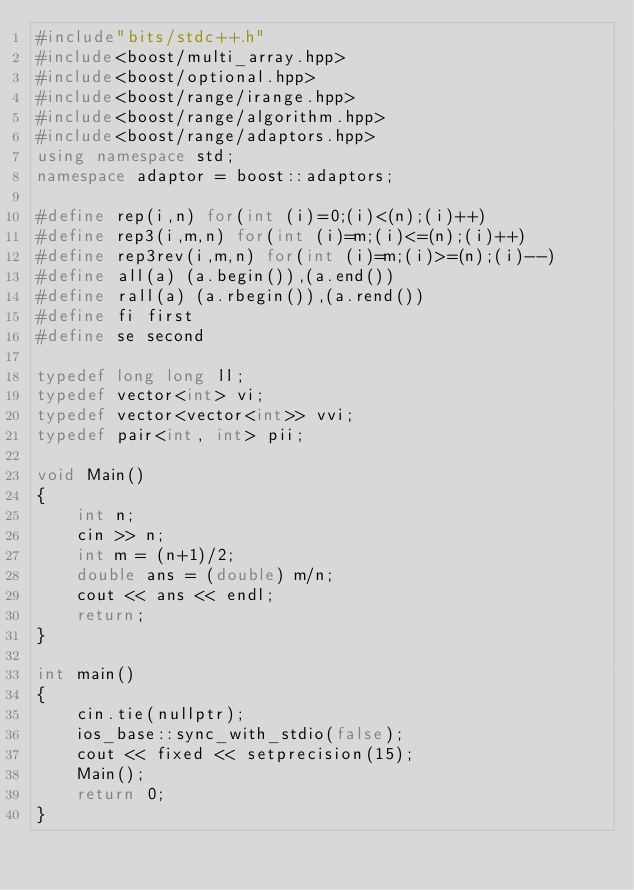Convert code to text. <code><loc_0><loc_0><loc_500><loc_500><_C++_>#include"bits/stdc++.h"
#include<boost/multi_array.hpp>
#include<boost/optional.hpp>
#include<boost/range/irange.hpp>
#include<boost/range/algorithm.hpp>
#include<boost/range/adaptors.hpp>
using namespace std;
namespace adaptor = boost::adaptors;

#define rep(i,n) for(int (i)=0;(i)<(n);(i)++)
#define rep3(i,m,n) for(int (i)=m;(i)<=(n);(i)++)
#define rep3rev(i,m,n) for(int (i)=m;(i)>=(n);(i)--)
#define all(a) (a.begin()),(a.end())
#define rall(a) (a.rbegin()),(a.rend())
#define fi first
#define se second

typedef long long ll;
typedef vector<int> vi;
typedef vector<vector<int>> vvi;
typedef pair<int, int> pii;

void Main()
{
	int n;
  	cin >> n;
  	int m = (n+1)/2;
  	double ans = (double) m/n;
  	cout << ans << endl;
	return;
}

int main()
{
	cin.tie(nullptr);
	ios_base::sync_with_stdio(false);
	cout << fixed << setprecision(15);
	Main();
	return 0;
}</code> 